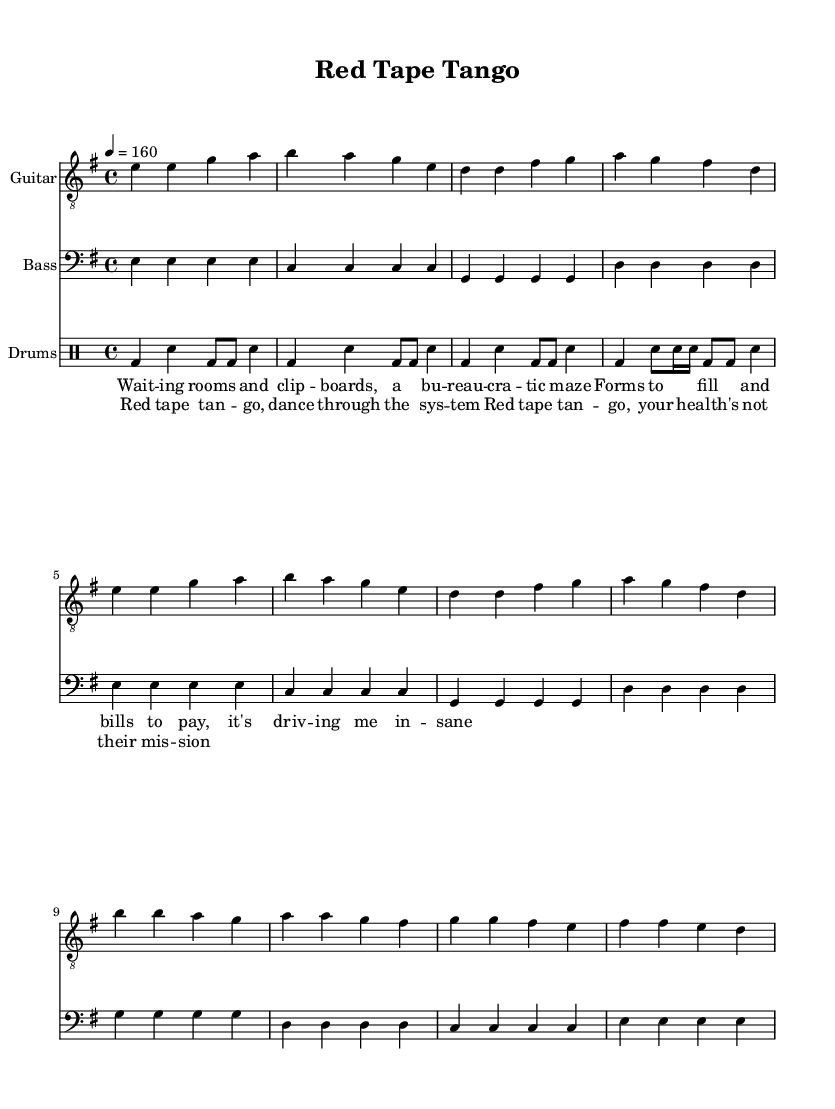What is the key signature of this music? The key signature is E minor, which has one sharp (F#). This can be identified by looking at the beginning of the staff where the sharps are indicated.
Answer: E minor What is the time signature of this piece? The time signature is 4/4, meaning there are four beats per measure, and the quarter note gets one beat. This can be found at the beginning of the score following the key signature.
Answer: 4/4 What is the tempo marking for this song? The tempo marking is 160, which indicates a fast pace of four beats per minute. This is specified in the tempo directive at the start of the sheet music.
Answer: 160 How many measures are in the verse section? The verse section contains 8 measures, which can be counted by examining the music notation for the verse lyrics and their corresponding measures in the guitar, bass, and drums staff.
Answer: 8 What style of beat is used in the drums section? The drums section showcases a basic punk beat, characterized by a simplicity and energy typical of punk music. This is evident from the rhythmic patterns and use of bass and snare drum in the drummode.
Answer: punk What is the primary lyrical theme of "Red Tape Tango"? The primary lyrical theme critiques bureaucracy and the complexities of the healthcare system, as highlighted in the verse lyrics. This commentary reflects the frustrations of navigating through forms, bills, and waiting rooms.
Answer: bureaucracy What is the dynamic nature of the chorus section? The chorus section is generally more intense and energetic compared to the verse, emphasizing the frustration expressed in the lyrics about the healthcare system. This contrast is supported by the repetitive and driving rhythm of the music during the chorus.
Answer: intense 